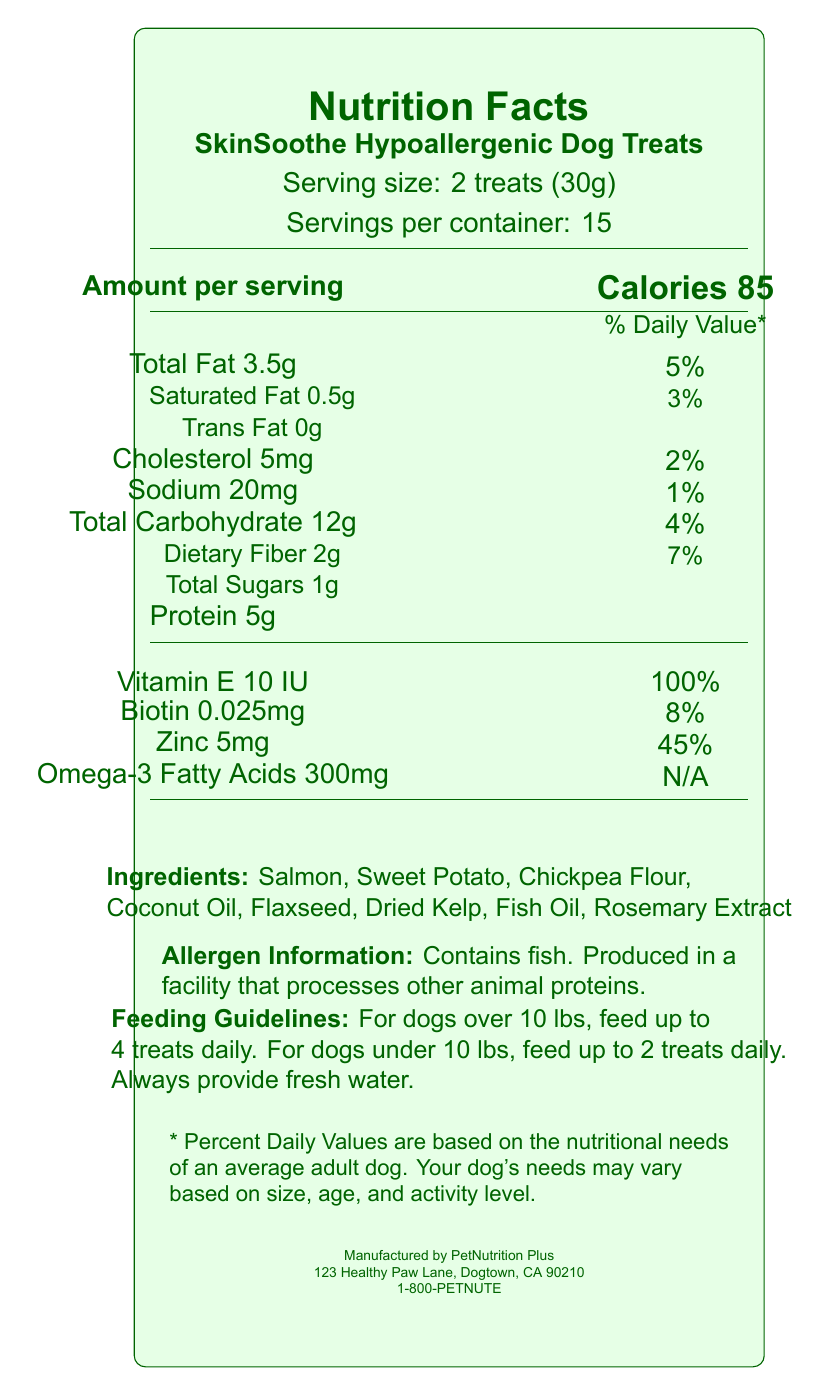what is the serving size for SkinSoothe Hypoallergenic Dog Treats? The document specifies that the serving size is 2 treats (30g).
Answer: 2 treats (30g) how many calories are in one serving? The document states that each serving contains 85 calories.
Answer: 85 what are the main ingredients of the treats? The list of ingredients includes these items as mentioned in the document.
Answer: Salmon, Sweet Potato, Chickpea Flour, Coconut Oil, Flaxseed, Dried Kelp, Fish Oil, Rosemary Extract how much total fat is in each serving, and what is the daily value percentage? Each serving contains 3.5g of total fat, which is 5% of the daily value.
Answer: 3.5g, 5% what is the amount of omega-3 fatty acids provided per serving? The document states that each serving contains 300mg of omega-3 fatty acids.
Answer: 300mg which vitamins and minerals are included in the treats? A. Vitamin D, Calcium, Iron B. Vitamin E, Biotin, Zinc, Omega-3 Fatty Acids C. Vitamin A, Potassium, Magnesium The treats contain Vitamin E, Biotin, Zinc, and Omega-3 Fatty Acids as per the document.
Answer: B how many servings are there in one container? A. 10 B. 15 C. 20 D. 25 The document mentions there are 15 servings per container.
Answer: B is there any cholesterol in these treats? The document states that each serving contains 5mg of cholesterol.
Answer: Yes, 5mg describe the feeding guidelines for these treats. The feeding guidelines specify the number of treats based on the dog's weight and recommend providing fresh water.
Answer: For dogs over 10 lbs, feed up to 4 treats daily. For dogs under 10 lbs, feed up to 2 treats daily. Always provide fresh water. does the product contain any artificial colors, flavors, or preservatives? One of the product claims listed is "No artificial colors, flavors, or preservatives."
Answer: No how much dietary fiber is included per serving, and what is the daily value percentage? Each serving contains 2g of dietary fiber, which is 7% of the daily value.
Answer: 2g, 7% what is the manufacturer's contact information? The document lists the manufacturer's contact as 1-800-PETNUTE.
Answer: 1-800-PETNUTE can this document tell us how much protein is recommended for an adult dog per day? The document does not provide information on the daily recommended amount of protein for an adult dog.
Answer: Cannot be determined summarize the main benefits of SkinSoothe Hypoallergenic Dog Treats. The main benefits include being hypoallergenic, supporting skin, coat, and digestive health, and not containing any artificial colors, flavors, or preservatives.
Answer: These treats are designed for sensitive skin, containing hypoallergenic ingredients to reduce allergic reactions, and provide skin and coat health benefits from omega-3 fatty acids and biotin. They also support digestive health with added fiber and contain no artificial additives. 